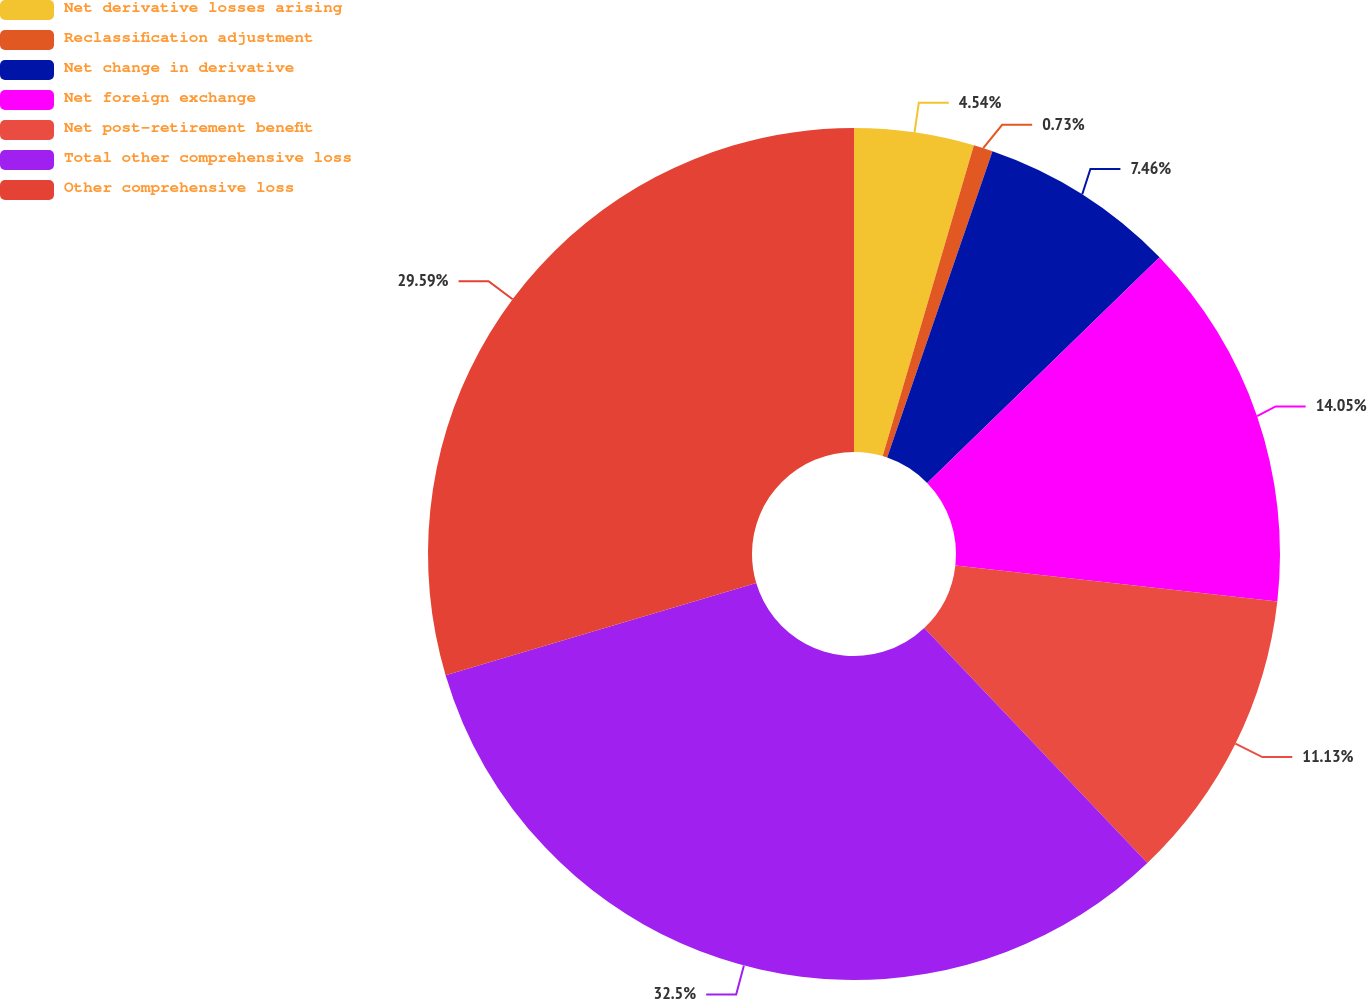<chart> <loc_0><loc_0><loc_500><loc_500><pie_chart><fcel>Net derivative losses arising<fcel>Reclassification adjustment<fcel>Net change in derivative<fcel>Net foreign exchange<fcel>Net post-retirement benefit<fcel>Total other comprehensive loss<fcel>Other comprehensive loss<nl><fcel>4.54%<fcel>0.73%<fcel>7.46%<fcel>14.05%<fcel>11.13%<fcel>32.5%<fcel>29.59%<nl></chart> 